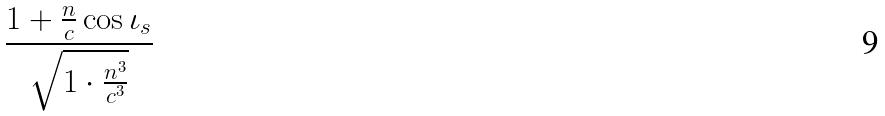<formula> <loc_0><loc_0><loc_500><loc_500>\frac { 1 + \frac { n } { c } \cos \iota _ { s } } { \sqrt { 1 \cdot \frac { n ^ { 3 } } { c ^ { 3 } } } }</formula> 